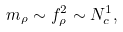<formula> <loc_0><loc_0><loc_500><loc_500>m _ { \rho } \sim f _ { \rho } ^ { 2 } \sim N _ { c } ^ { 1 } ,</formula> 